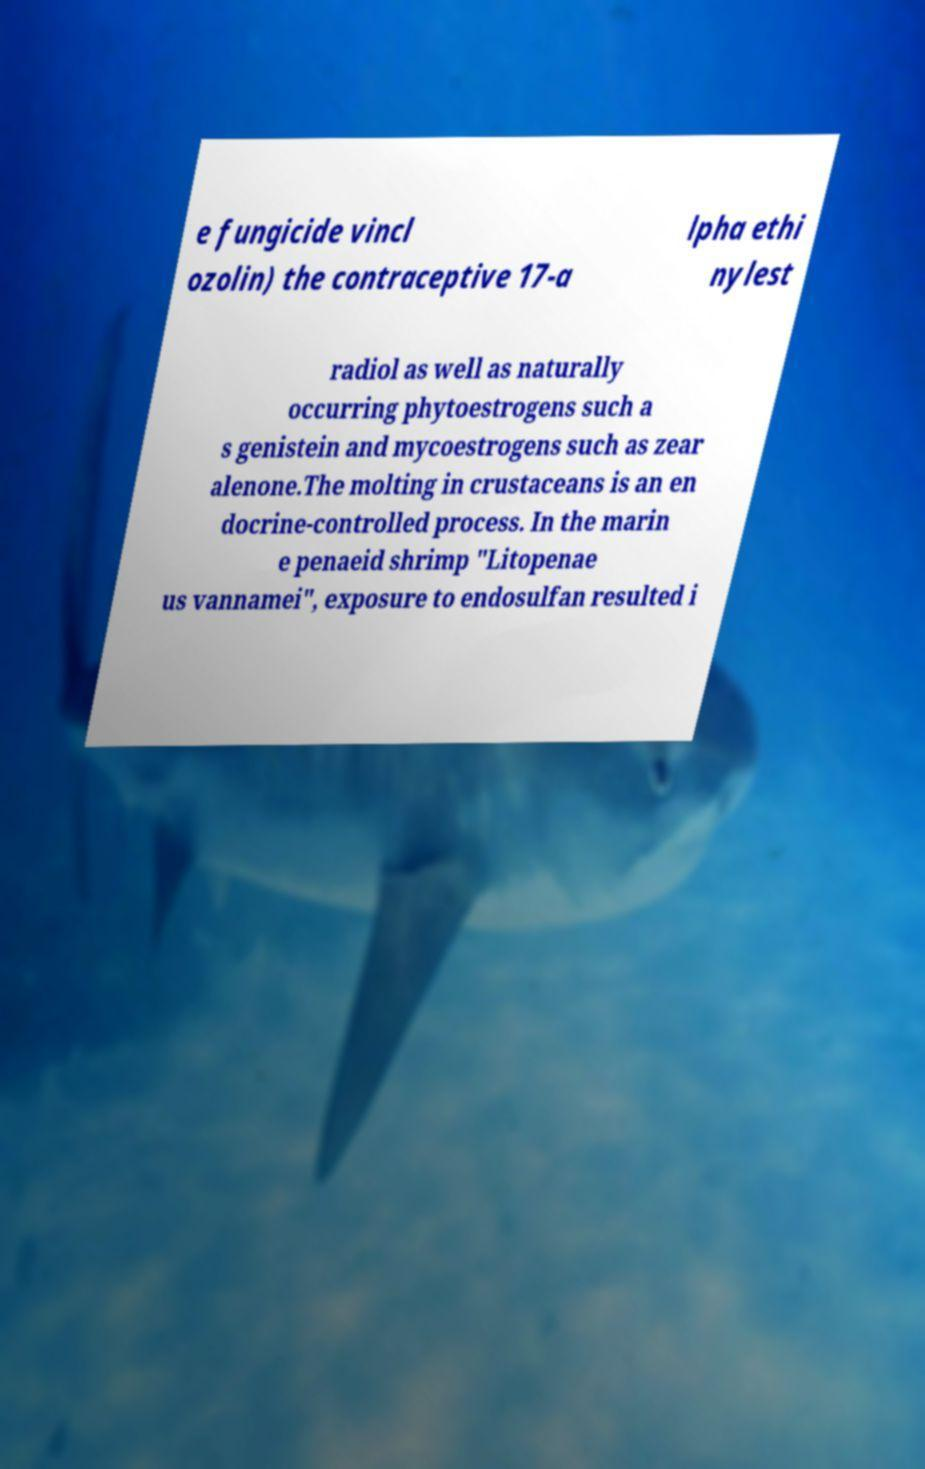There's text embedded in this image that I need extracted. Can you transcribe it verbatim? e fungicide vincl ozolin) the contraceptive 17-a lpha ethi nylest radiol as well as naturally occurring phytoestrogens such a s genistein and mycoestrogens such as zear alenone.The molting in crustaceans is an en docrine-controlled process. In the marin e penaeid shrimp "Litopenae us vannamei", exposure to endosulfan resulted i 